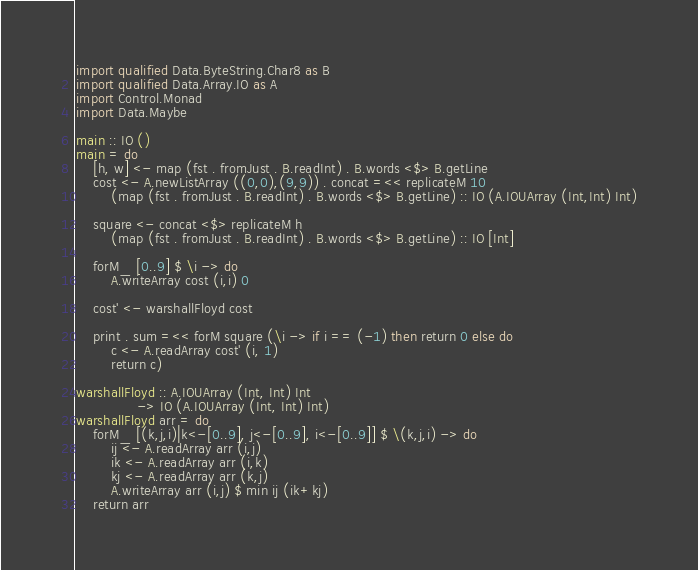Convert code to text. <code><loc_0><loc_0><loc_500><loc_500><_Haskell_>import qualified Data.ByteString.Char8 as B
import qualified Data.Array.IO as A
import Control.Monad
import Data.Maybe

main :: IO ()
main = do
    [h, w] <- map (fst . fromJust . B.readInt) . B.words <$> B.getLine
    cost <- A.newListArray ((0,0),(9,9)) . concat =<< replicateM 10
        (map (fst . fromJust . B.readInt) . B.words <$> B.getLine) :: IO (A.IOUArray (Int,Int) Int)

    square <- concat <$> replicateM h 
        (map (fst . fromJust . B.readInt) . B.words <$> B.getLine) :: IO [Int]

    forM_ [0..9] $ \i -> do
        A.writeArray cost (i,i) 0

    cost' <- warshallFloyd cost

    print . sum =<< forM square (\i -> if i == (-1) then return 0 else do
        c <- A.readArray cost' (i, 1)
        return c)

warshallFloyd :: A.IOUArray (Int, Int) Int
              -> IO (A.IOUArray (Int, Int) Int)
warshallFloyd arr = do
    forM_ [(k,j,i)|k<-[0..9], j<-[0..9], i<-[0..9]] $ \(k,j,i) -> do
        ij <- A.readArray arr (i,j)     
        ik <- A.readArray arr (i,k)     
        kj <- A.readArray arr (k,j)     
        A.writeArray arr (i,j) $ min ij (ik+kj)
    return arr</code> 